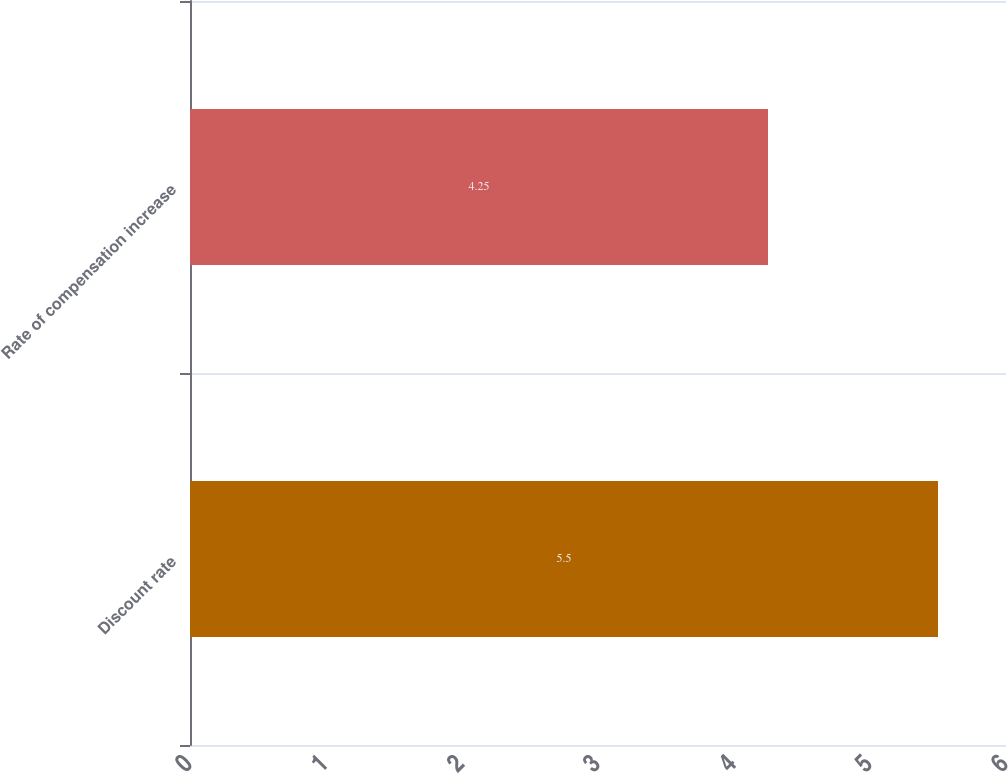<chart> <loc_0><loc_0><loc_500><loc_500><bar_chart><fcel>Discount rate<fcel>Rate of compensation increase<nl><fcel>5.5<fcel>4.25<nl></chart> 